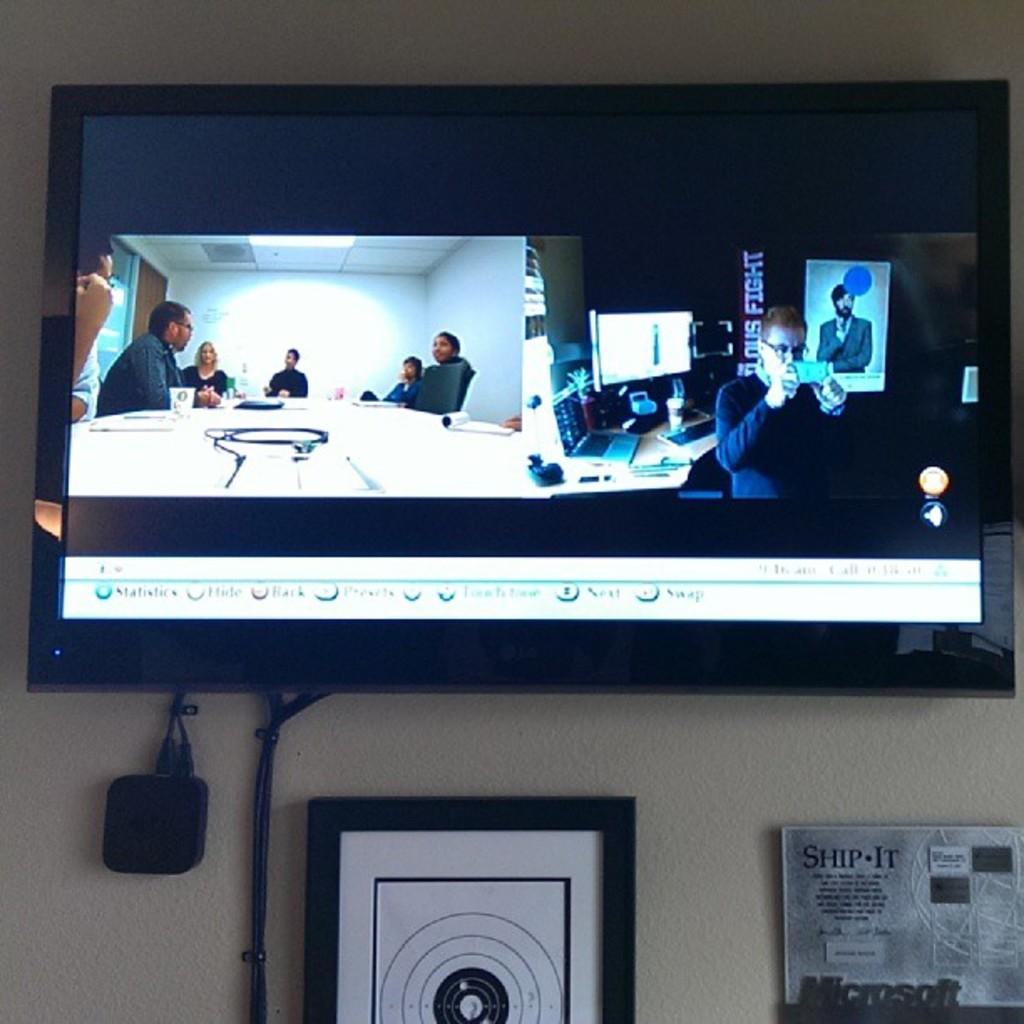<image>
Describe the image concisely. Monitors show two different rooms above a sign saying Ship It. 